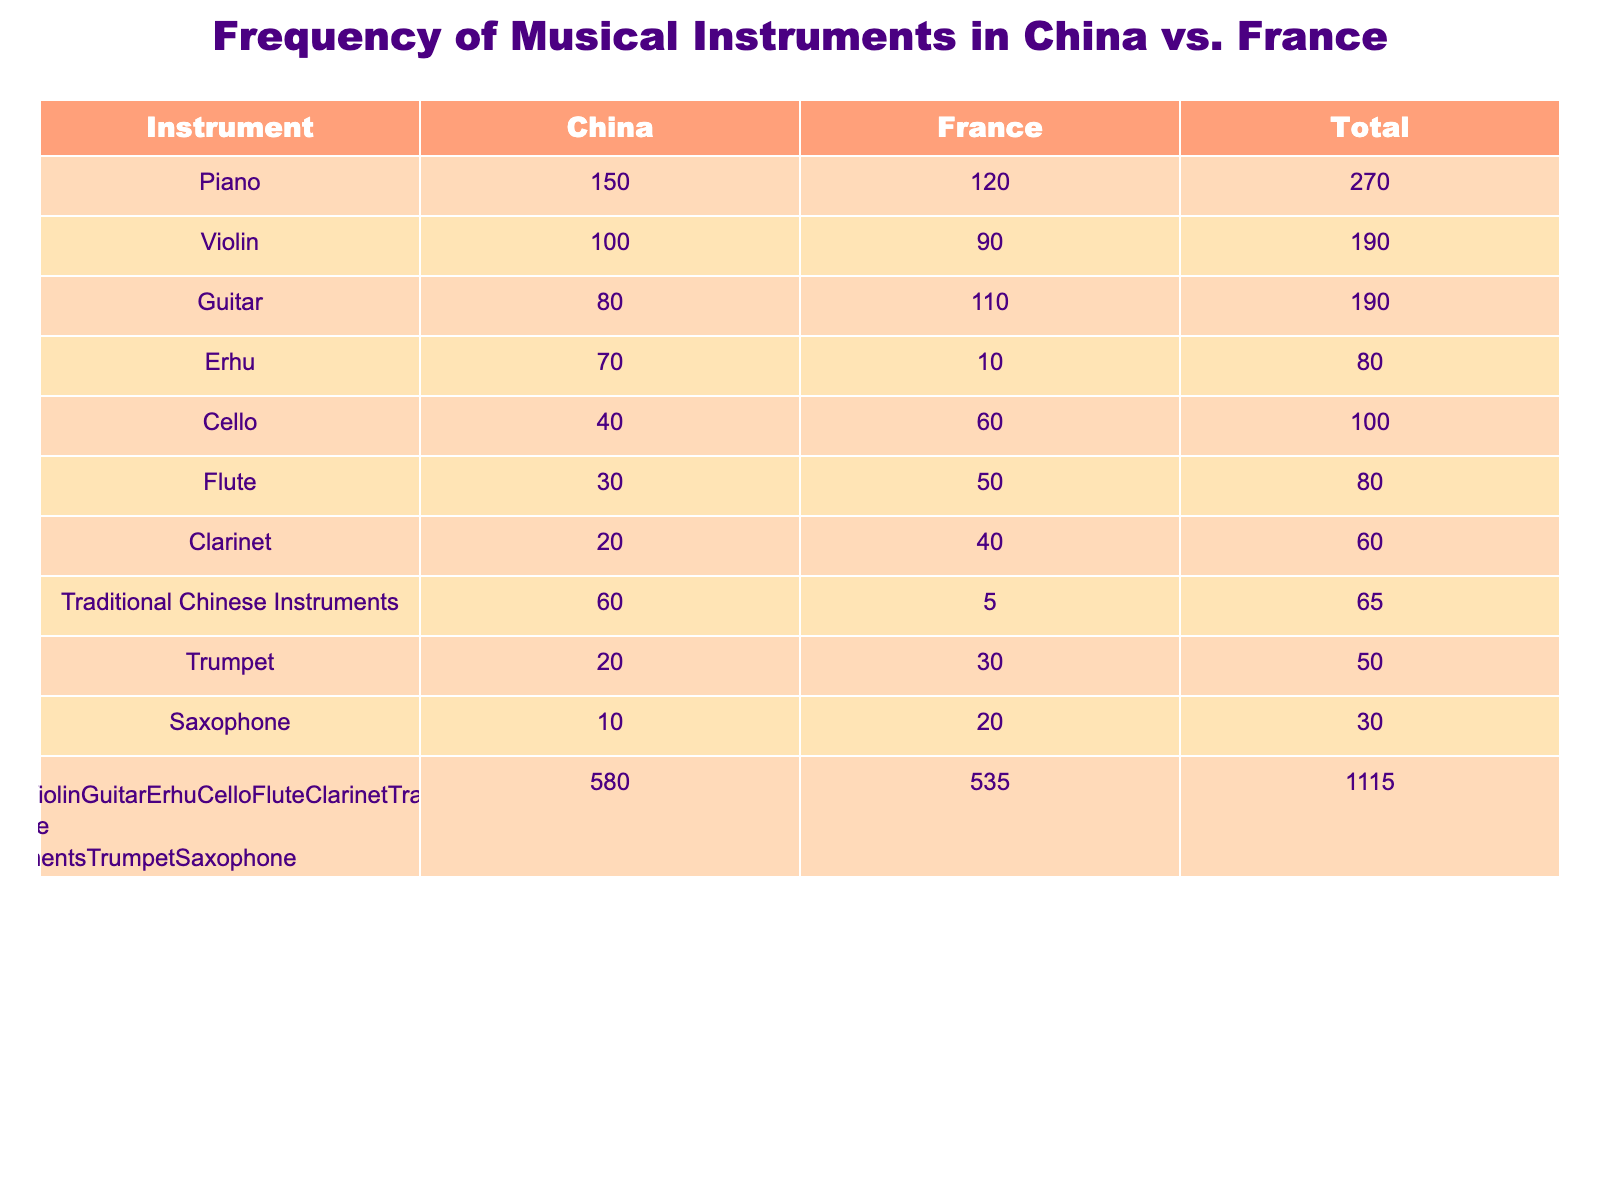What is the total number of young musicians playing the Erhu in China? The table shows that the number of young musicians playing the Erhu in China is 70. This value is directly obtained from the table under the China column for the Erhu row.
Answer: 70 Which instrument has the highest number of young musicians in China? Looking through the table, the Piano has 150 young musicians in China, which is greater than the numbers for all other instruments listed. Therefore, it has the highest frequency among young musicians in China.
Answer: Piano What is the difference in the number of young musicians playing the Guitar between China and France? The number of young musicians playing the Guitar in China is 80, while in France it is 110. To find the difference, we compute 110 - 80 = 30, indicating that more young musicians in France play the Guitar.
Answer: 30 Is the number of young musicians playing Traditional Chinese Instruments in France greater than those playing the Cello in China? According to the table, there are 5 young musicians playing Traditional Chinese Instruments in France and 40 playing the Cello in China. Since 5 is less than 40, the statement is false.
Answer: No What is the total number of young musicians playing musical instruments in France? To find the total number of young musicians in France, we sum up all the values in the France column: 120 (Piano) + 90 (Violin) + 110 (Guitar) + 10 (Erhu) + 60 (Cello) + 50 (Flute) + 40 (Clarinet) + 5 (Traditional Chinese Instruments) + 30 (Trumpet) + 20 (Saxophone) = 555. Therefore, the total is 555.
Answer: 555 Which country has a higher total number of young musicians playing woodwind instruments? In the table, for woodwind instruments (Flute, Clarinet, and Saxophone), France has 50 (Flute) + 40 (Clarinet) + 20 (Saxophone) = 110, while China has 30 (Flute) + 20 (Clarinet) + 10 (Saxophone) = 60. Thus, France has a higher total number of young musicians playing woodwind instruments.
Answer: France What percentage of young musicians in China play the Violin? The total number of young musicians in China is 150 (Piano) + 100 (Violin) + 80 (Guitar) + 70 (Erhu) + 40 (Cello) + 30 (Flute) + 20 (Clarinet) + 60 (Traditional Chinese Instruments) + 20 (Trumpet) + 10 (Saxophone) = 680. The number of Violin players is 100. To find the percentage, (100/680) * 100 ≈ 14.71%.
Answer: Approximately 14.71% Is there a greater number of young musicians playing the Cello in China compared to the Erhu in France? There are 40 young musicians playing the Cello in China and only 10 playing the Erhu in France. Since 40 is greater than 10, the answer is yes.
Answer: Yes 